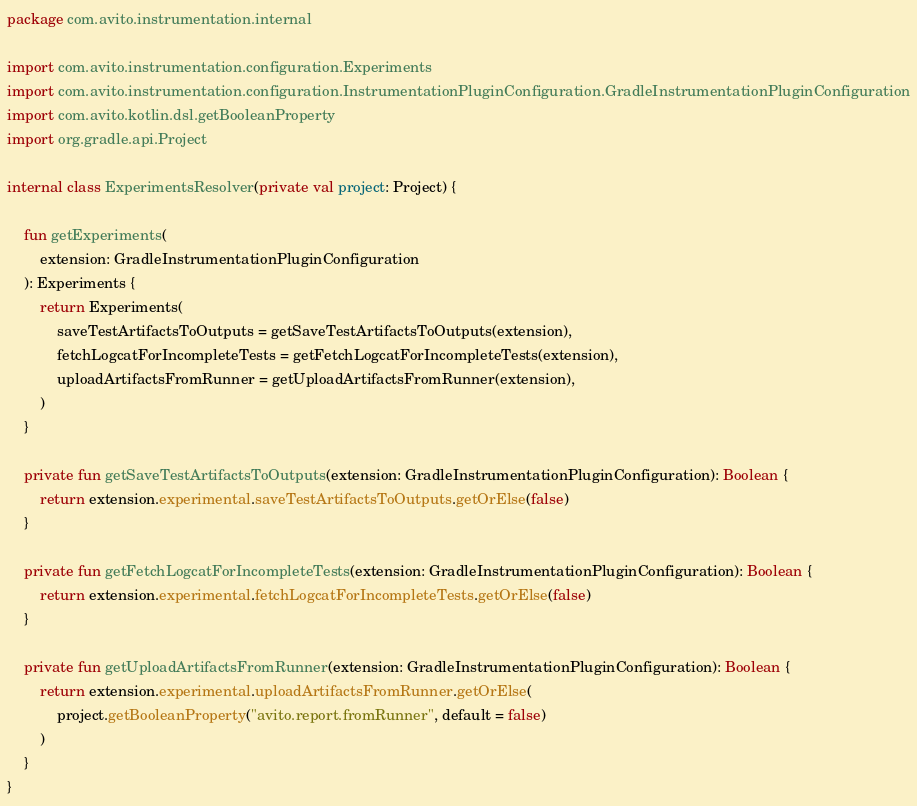<code> <loc_0><loc_0><loc_500><loc_500><_Kotlin_>package com.avito.instrumentation.internal

import com.avito.instrumentation.configuration.Experiments
import com.avito.instrumentation.configuration.InstrumentationPluginConfiguration.GradleInstrumentationPluginConfiguration
import com.avito.kotlin.dsl.getBooleanProperty
import org.gradle.api.Project

internal class ExperimentsResolver(private val project: Project) {

    fun getExperiments(
        extension: GradleInstrumentationPluginConfiguration
    ): Experiments {
        return Experiments(
            saveTestArtifactsToOutputs = getSaveTestArtifactsToOutputs(extension),
            fetchLogcatForIncompleteTests = getFetchLogcatForIncompleteTests(extension),
            uploadArtifactsFromRunner = getUploadArtifactsFromRunner(extension),
        )
    }

    private fun getSaveTestArtifactsToOutputs(extension: GradleInstrumentationPluginConfiguration): Boolean {
        return extension.experimental.saveTestArtifactsToOutputs.getOrElse(false)
    }

    private fun getFetchLogcatForIncompleteTests(extension: GradleInstrumentationPluginConfiguration): Boolean {
        return extension.experimental.fetchLogcatForIncompleteTests.getOrElse(false)
    }

    private fun getUploadArtifactsFromRunner(extension: GradleInstrumentationPluginConfiguration): Boolean {
        return extension.experimental.uploadArtifactsFromRunner.getOrElse(
            project.getBooleanProperty("avito.report.fromRunner", default = false)
        )
    }
}
</code> 